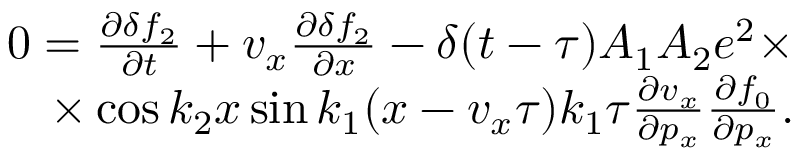Convert formula to latex. <formula><loc_0><loc_0><loc_500><loc_500>\begin{array} { r } { 0 = \frac { \partial \delta f _ { 2 } } { \partial t } + v _ { x } \frac { \partial \delta f _ { 2 } } { \partial x } - \delta ( t - \tau ) A _ { 1 } A _ { 2 } e ^ { 2 } \times } \\ { \times \cos k _ { 2 } x \sin k _ { 1 } ( x - v _ { x } \tau ) k _ { 1 } \tau \frac { \partial v _ { x } } { \partial p _ { x } } \frac { \partial f _ { 0 } } { \partial p _ { x } } . } \end{array}</formula> 